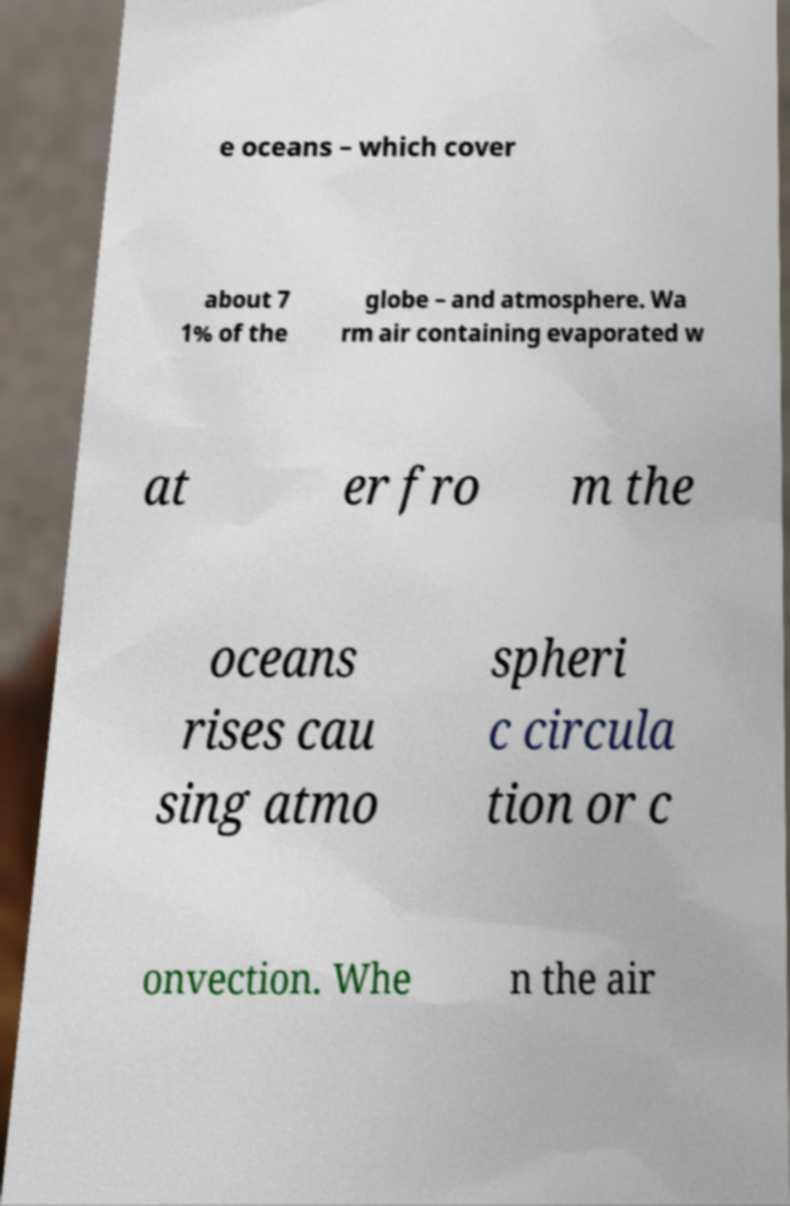Please identify and transcribe the text found in this image. e oceans – which cover about 7 1% of the globe – and atmosphere. Wa rm air containing evaporated w at er fro m the oceans rises cau sing atmo spheri c circula tion or c onvection. Whe n the air 